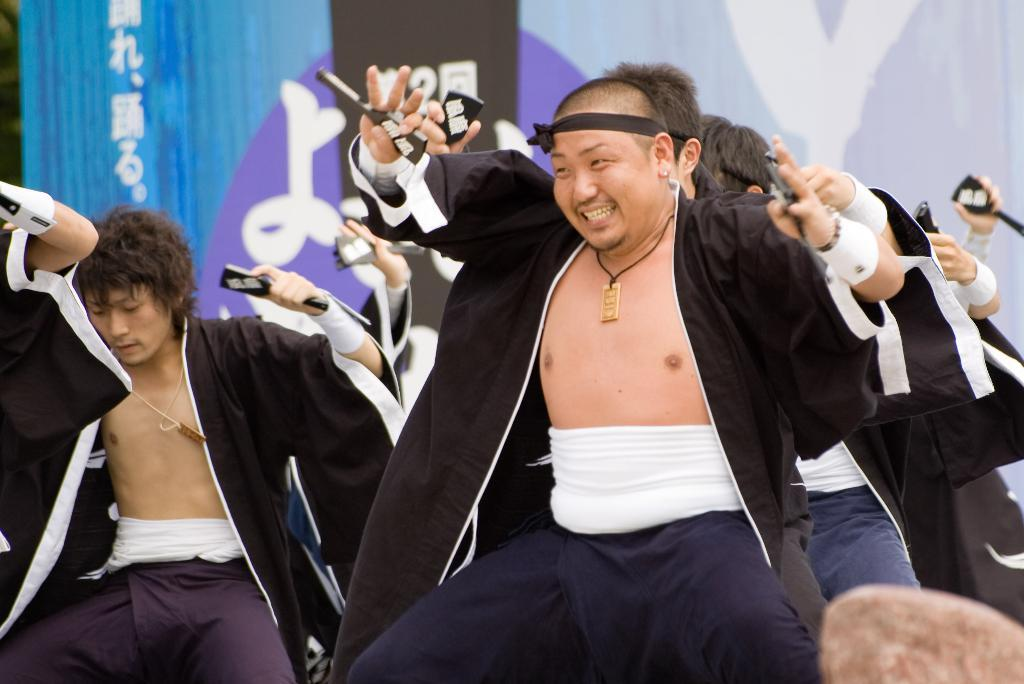What is happening in the image involving the group of people? The people are dancing in the image. What are the people holding while dancing? The people are holding objects in the image. What can be seen in the background of the image? There is a board in the background of the image. What is written or depicted on the board? There is text on the board in the image. What type of locket is hanging around the neck of the person in the image? There is no locket visible in the image; the focus is on the group of people dancing and holding objects. 